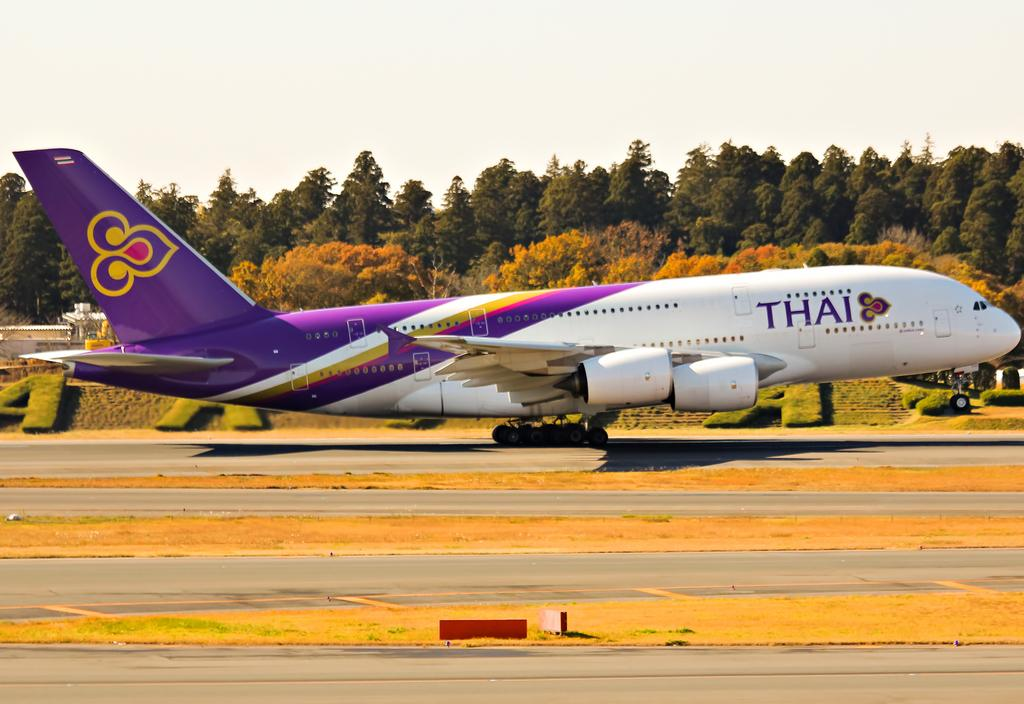<image>
Summarize the visual content of the image. A large airliner with the word Thai on the side. 